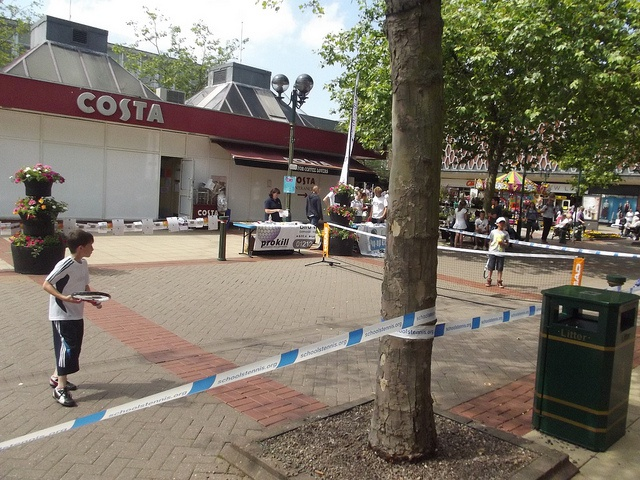Describe the objects in this image and their specific colors. I can see people in gray, black, and darkgray tones, people in gray, black, darkgray, and lightgray tones, people in gray, black, ivory, and darkgray tones, umbrella in gray, khaki, darkgray, lightpink, and tan tones, and people in gray, white, darkgray, and black tones in this image. 